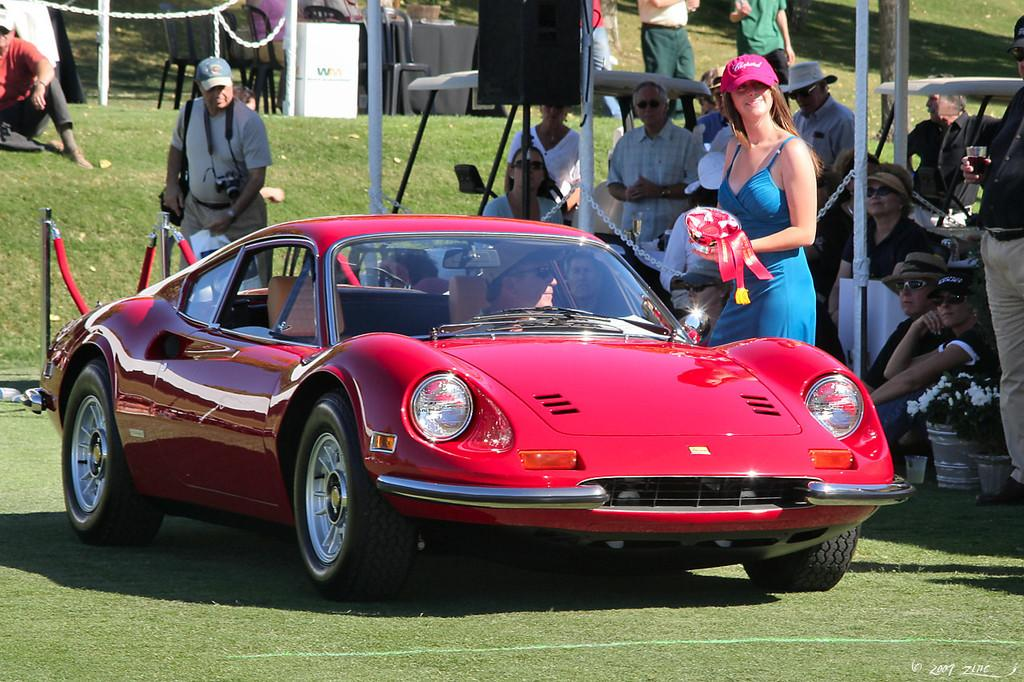What is located in the foreground of the image? In the foreground of the image, there is a car, grass, a woman, and a railing. Can you describe the woman in the foreground? The woman in the foreground is standing near the car and the railing. What can be seen in the background of the image? In the background of the image, there are people, poles, speakers, tents, couches, chairs, and grass, as well as other objects. What wealth-related information can be gathered from the caption of the image? There is no caption provided with the image, so no wealth-related information can be gathered. 